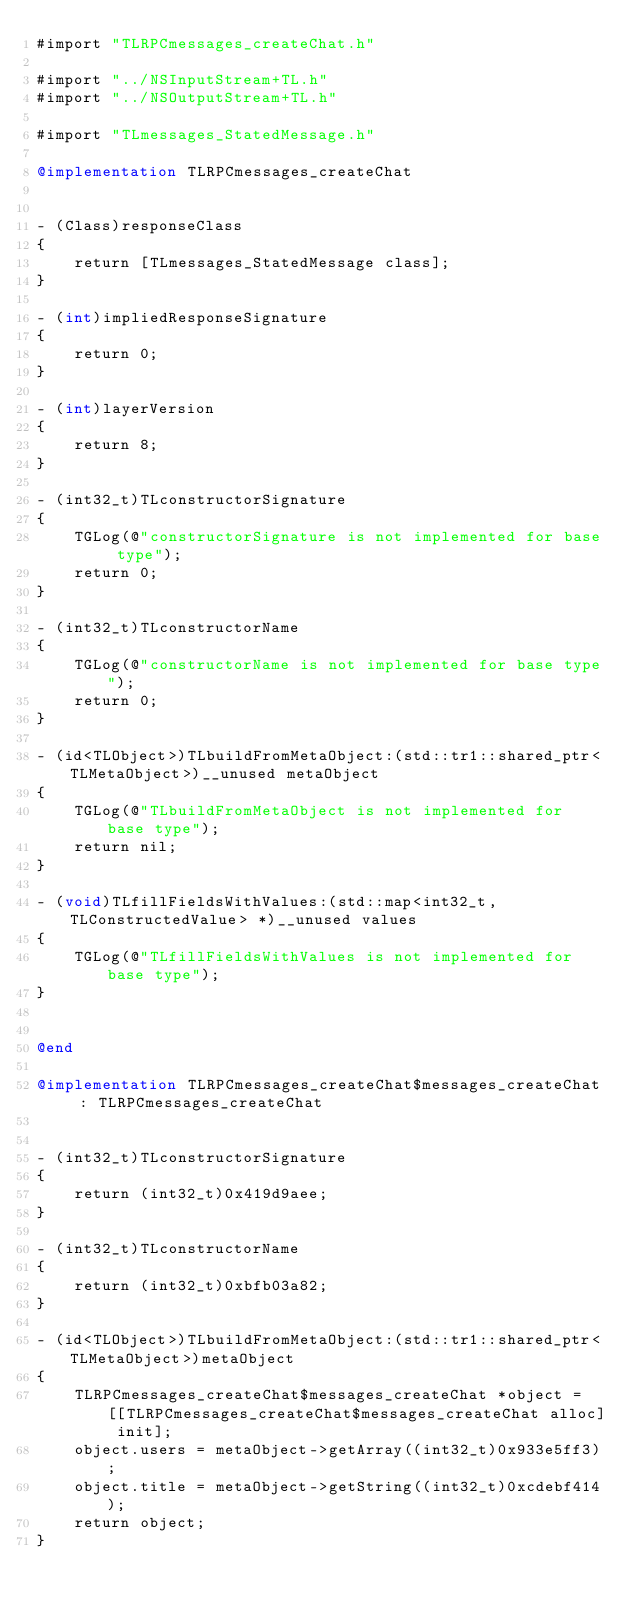Convert code to text. <code><loc_0><loc_0><loc_500><loc_500><_ObjectiveC_>#import "TLRPCmessages_createChat.h"

#import "../NSInputStream+TL.h"
#import "../NSOutputStream+TL.h"

#import "TLmessages_StatedMessage.h"

@implementation TLRPCmessages_createChat


- (Class)responseClass
{
    return [TLmessages_StatedMessage class];
}

- (int)impliedResponseSignature
{
    return 0;
}

- (int)layerVersion
{
    return 8;
}

- (int32_t)TLconstructorSignature
{
    TGLog(@"constructorSignature is not implemented for base type");
    return 0;
}

- (int32_t)TLconstructorName
{
    TGLog(@"constructorName is not implemented for base type");
    return 0;
}

- (id<TLObject>)TLbuildFromMetaObject:(std::tr1::shared_ptr<TLMetaObject>)__unused metaObject
{
    TGLog(@"TLbuildFromMetaObject is not implemented for base type");
    return nil;
}

- (void)TLfillFieldsWithValues:(std::map<int32_t, TLConstructedValue> *)__unused values
{
    TGLog(@"TLfillFieldsWithValues is not implemented for base type");
}


@end

@implementation TLRPCmessages_createChat$messages_createChat : TLRPCmessages_createChat


- (int32_t)TLconstructorSignature
{
    return (int32_t)0x419d9aee;
}

- (int32_t)TLconstructorName
{
    return (int32_t)0xbfb03a82;
}

- (id<TLObject>)TLbuildFromMetaObject:(std::tr1::shared_ptr<TLMetaObject>)metaObject
{
    TLRPCmessages_createChat$messages_createChat *object = [[TLRPCmessages_createChat$messages_createChat alloc] init];
    object.users = metaObject->getArray((int32_t)0x933e5ff3);
    object.title = metaObject->getString((int32_t)0xcdebf414);
    return object;
}
</code> 